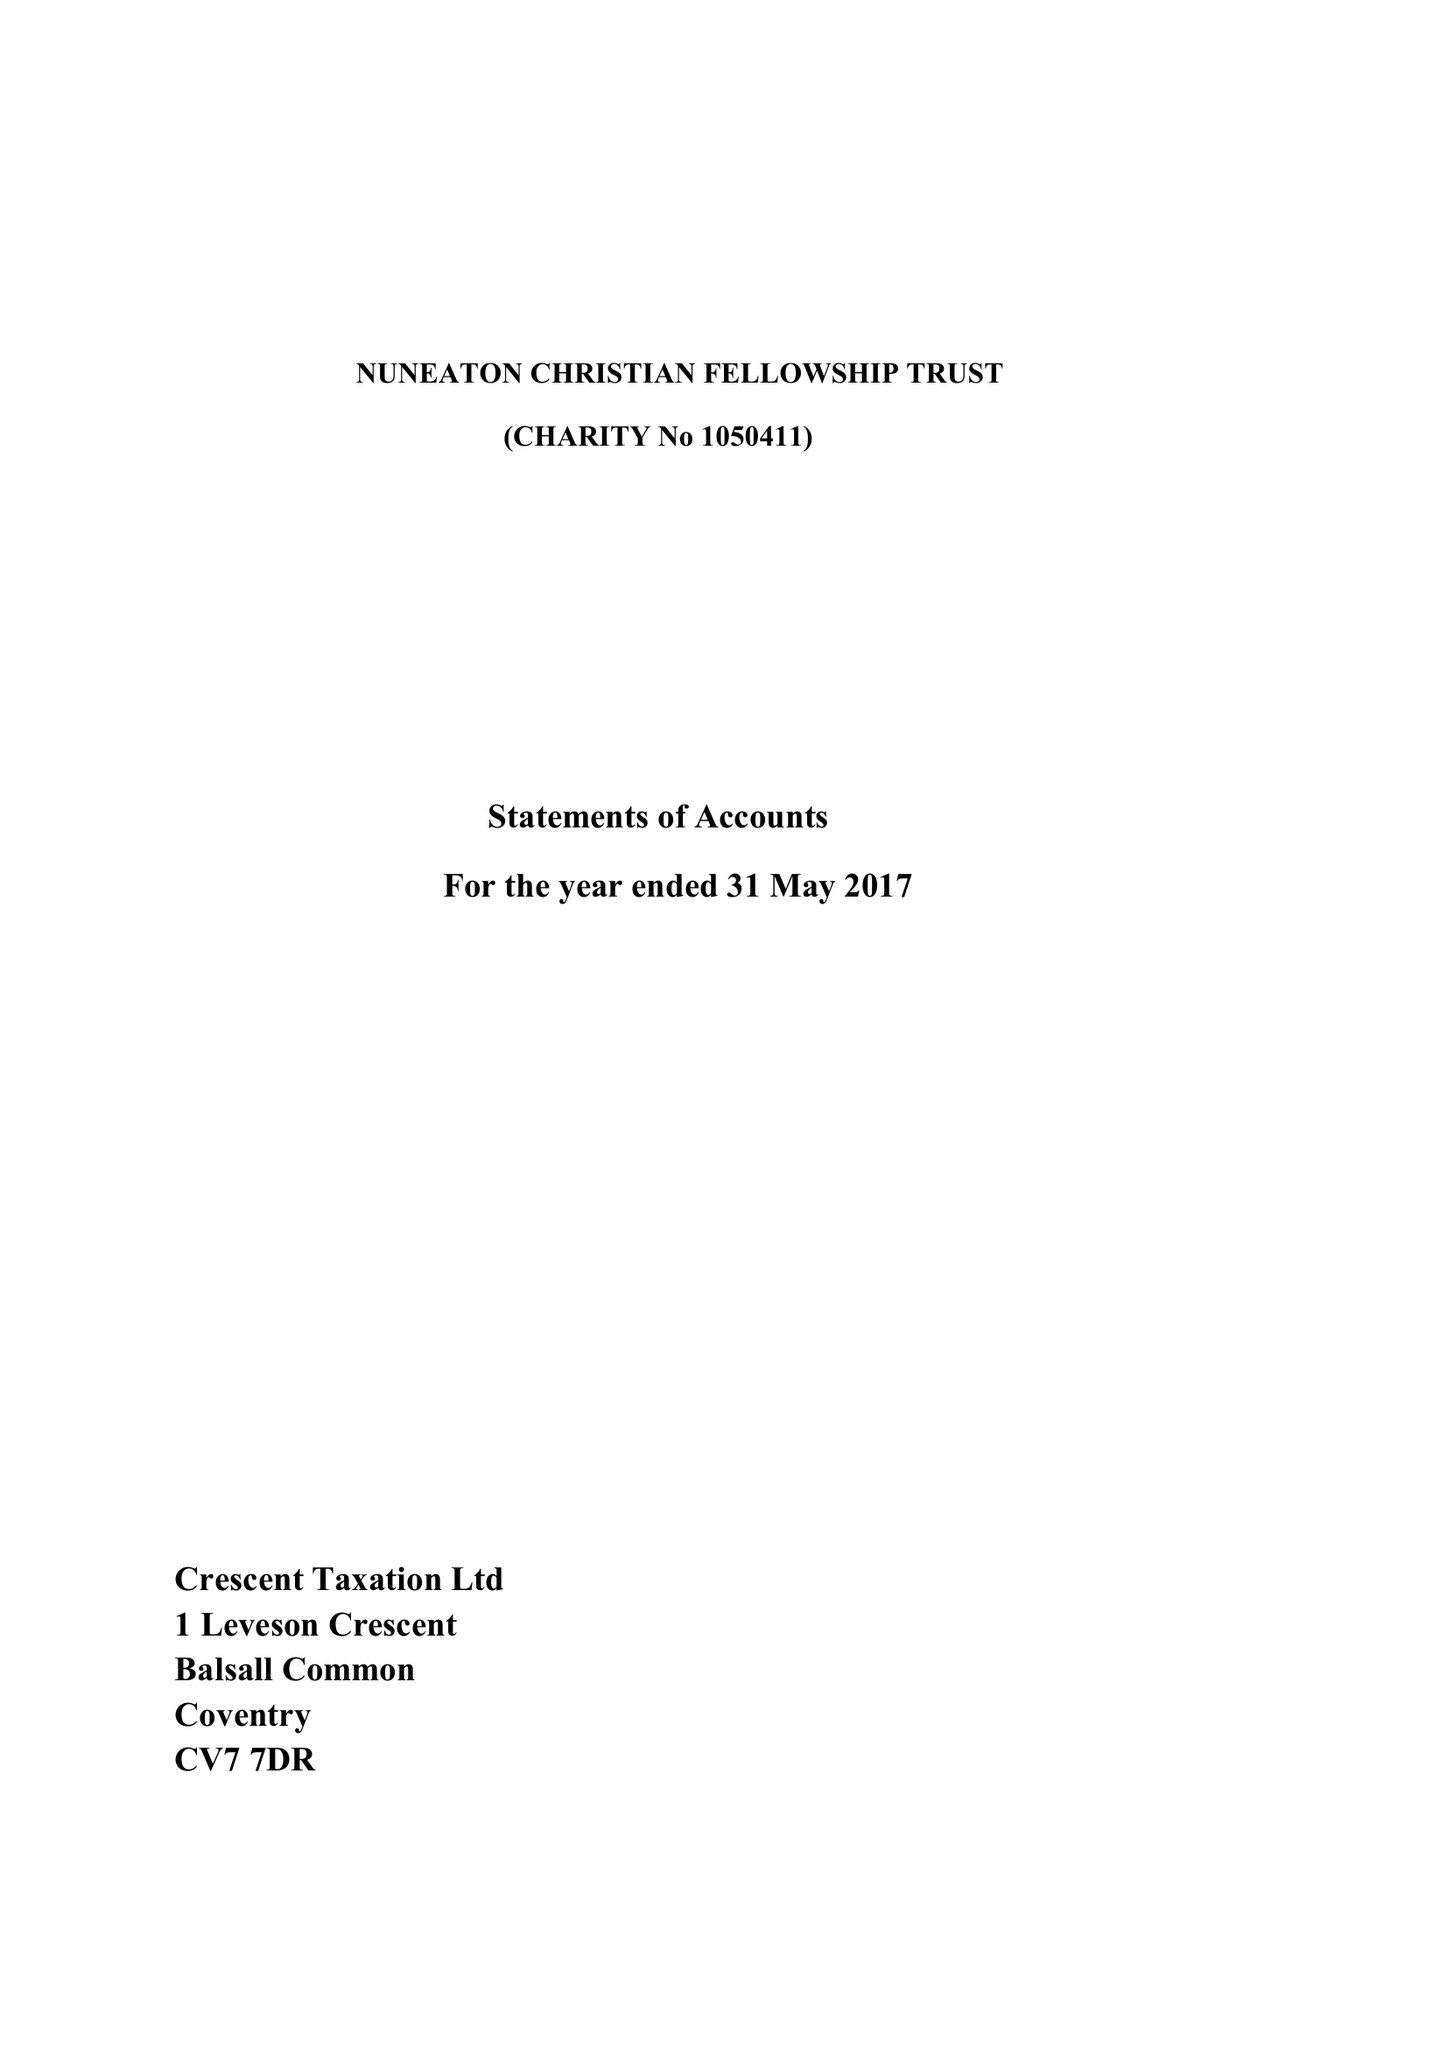What is the value for the charity_number?
Answer the question using a single word or phrase. 1054011 